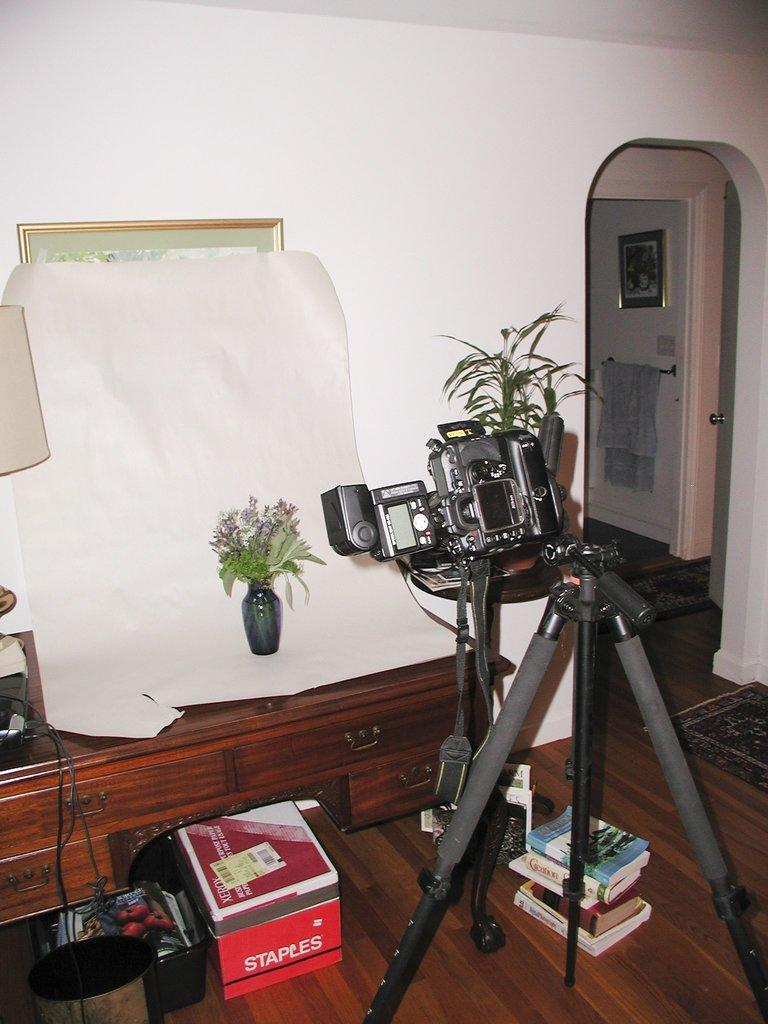What is the main object in the image? There is a tripod stand in the image. What other objects can be seen in the image? There are books, a camera, a box, a lamp, a flower vase, and a frame in the image. Can you describe the background of the image? There is a wall, a towel on a hanger, a door, and another frame in the background of the image. How does the sea affect the objects in the image? There is no sea present in the image, so it does not affect the objects. What direction does the bit turn in the image? There is no bit present in the image, so it cannot be determined how it would turn. 